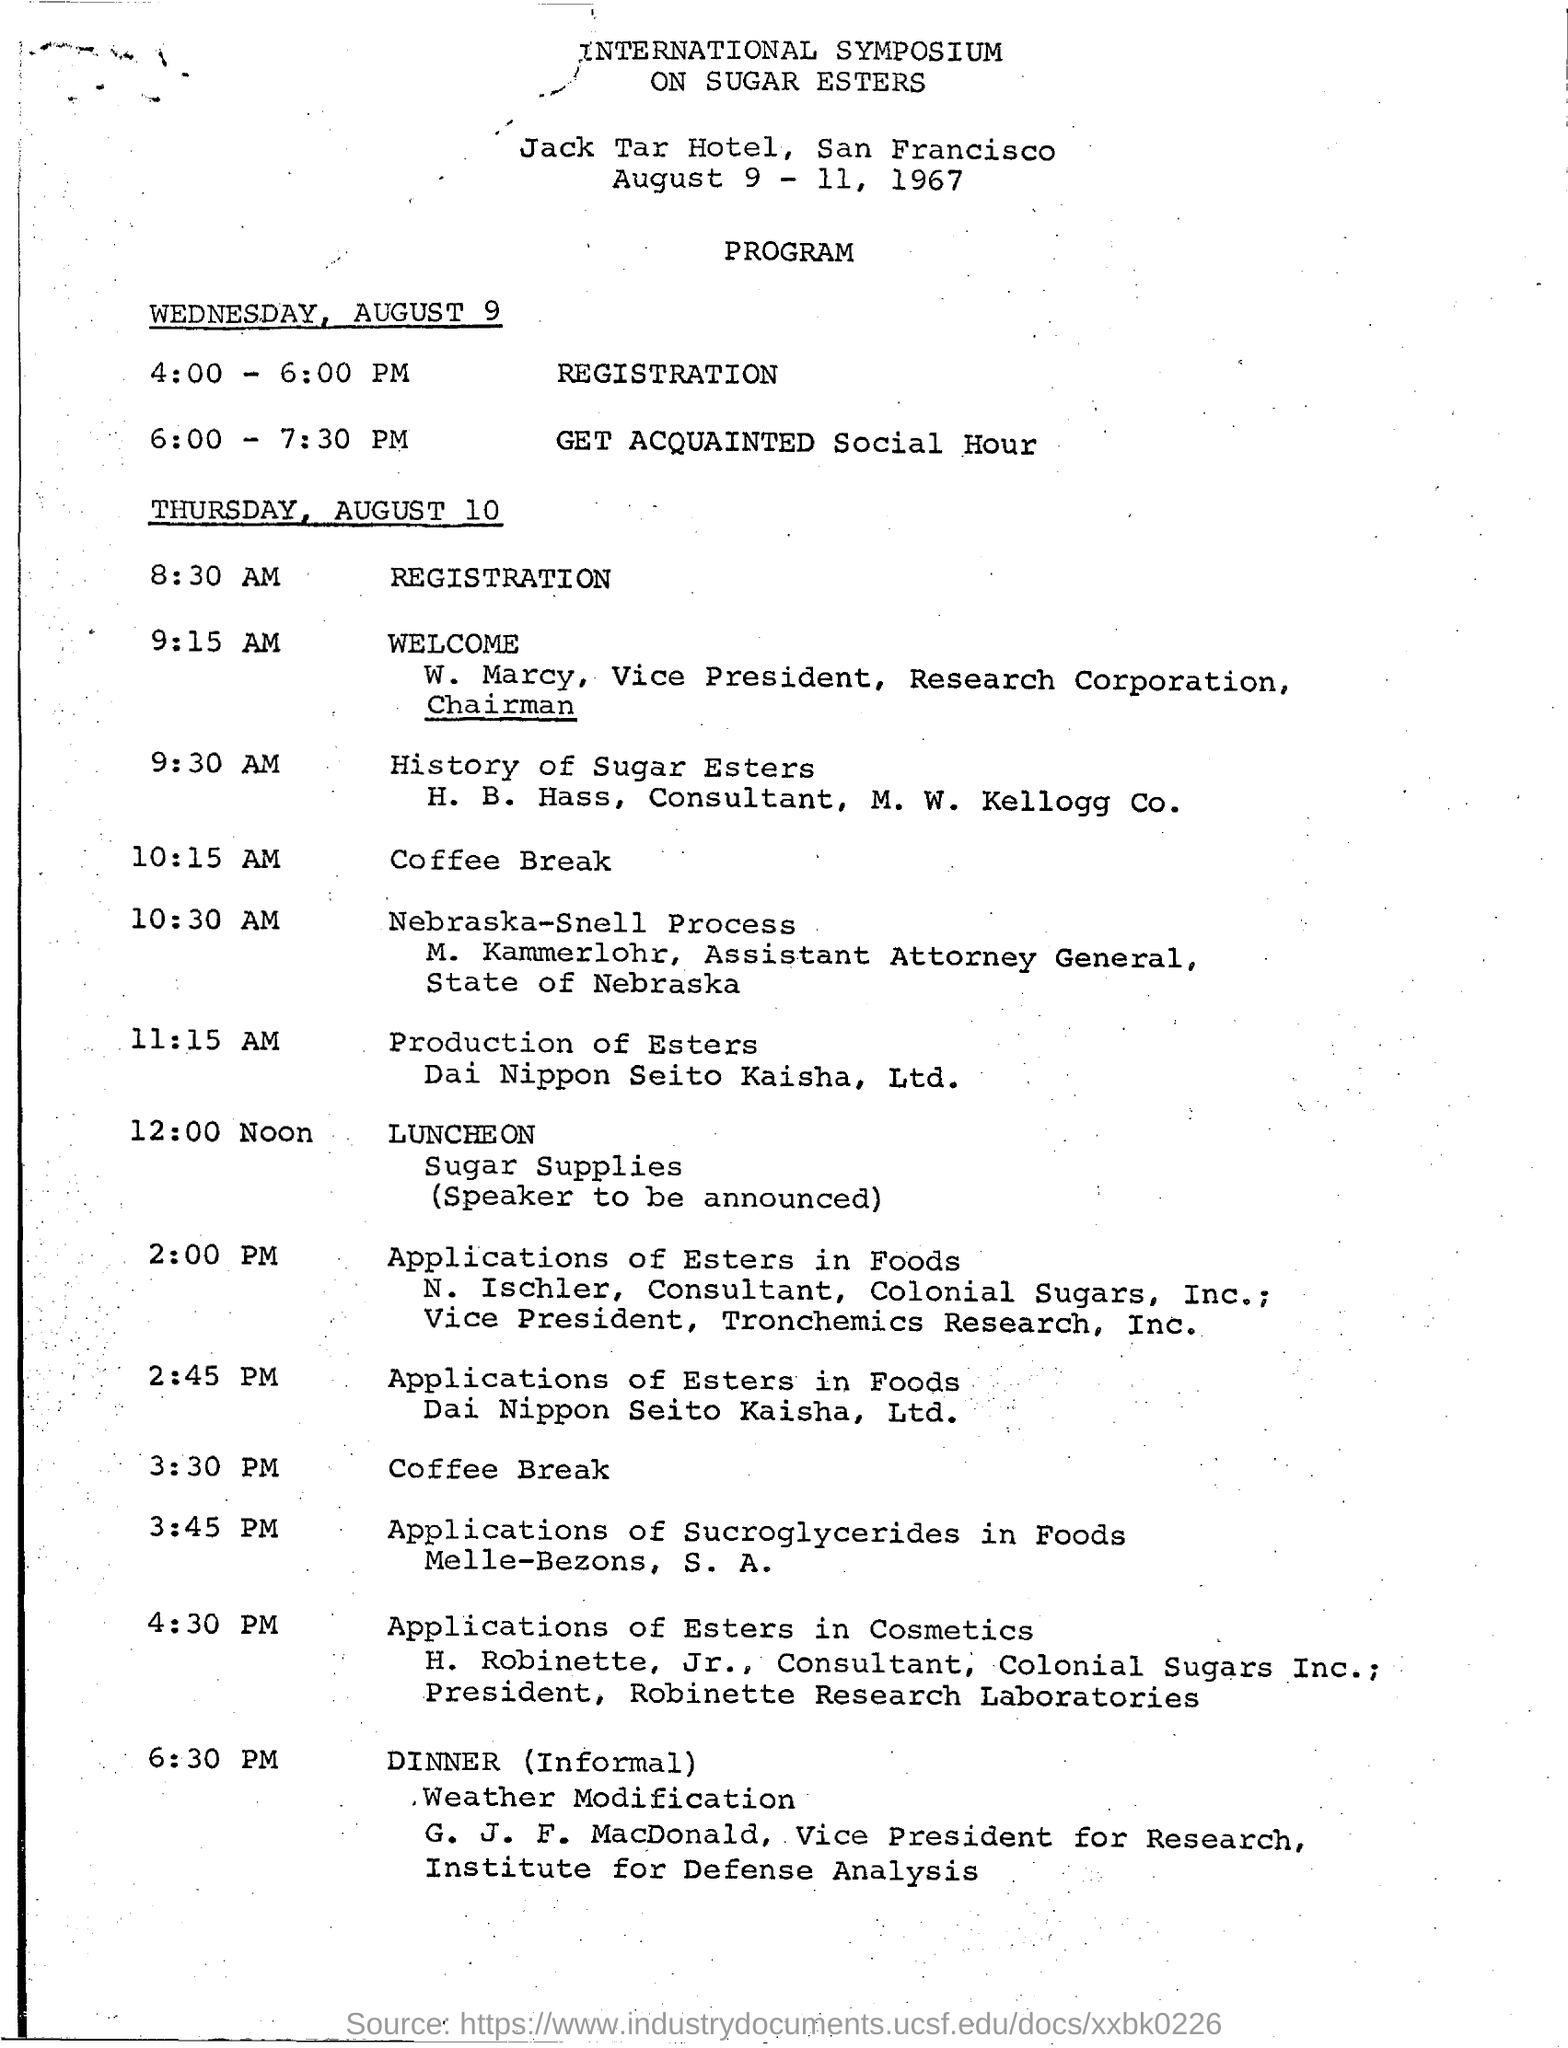What is the program at 4:00 - 6:00 pm on wednesday , august 9 ?
Your answer should be compact. Registration. What is the program that is scheduled between 6:00 - 7:30 pm ?
Make the answer very short. Get Acquainted Social Hour. What is the program that is scheduled at 8:30 am on thursday , august 10 ?
Offer a terse response. Registration. What is the program that is scheduled at 9:15 am on thursday , august 10 ?
Your response must be concise. Welcome. What is the program at the time of 12:00 noon ?
Your answer should be compact. Luncheon. 